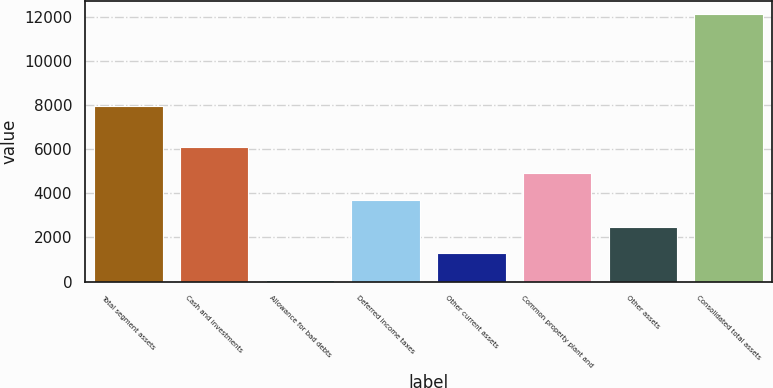<chart> <loc_0><loc_0><loc_500><loc_500><bar_chart><fcel>Total segment assets<fcel>Cash and investments<fcel>Allowance for bad debts<fcel>Deferred income taxes<fcel>Other current assets<fcel>Common property plant and<fcel>Other assets<fcel>Consolidated total assets<nl><fcel>7932<fcel>6094.5<fcel>87<fcel>3691.5<fcel>1288.5<fcel>4893<fcel>2490<fcel>12102<nl></chart> 